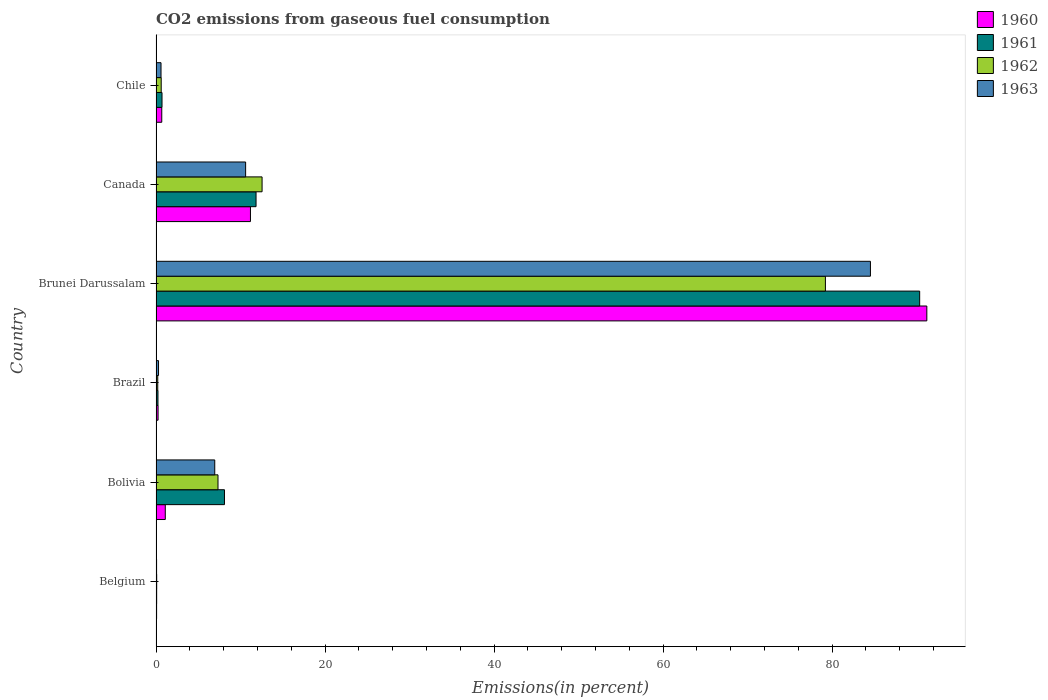How many different coloured bars are there?
Ensure brevity in your answer.  4. Are the number of bars per tick equal to the number of legend labels?
Your answer should be very brief. Yes. Are the number of bars on each tick of the Y-axis equal?
Keep it short and to the point. Yes. How many bars are there on the 1st tick from the top?
Provide a short and direct response. 4. What is the label of the 1st group of bars from the top?
Make the answer very short. Chile. What is the total CO2 emitted in 1960 in Brunei Darussalam?
Offer a terse response. 91.21. Across all countries, what is the maximum total CO2 emitted in 1960?
Provide a succinct answer. 91.21. Across all countries, what is the minimum total CO2 emitted in 1962?
Provide a short and direct response. 0.08. In which country was the total CO2 emitted in 1962 maximum?
Offer a very short reply. Brunei Darussalam. In which country was the total CO2 emitted in 1962 minimum?
Make the answer very short. Belgium. What is the total total CO2 emitted in 1960 in the graph?
Your answer should be very brief. 104.47. What is the difference between the total CO2 emitted in 1961 in Brunei Darussalam and that in Canada?
Make the answer very short. 78.52. What is the difference between the total CO2 emitted in 1960 in Chile and the total CO2 emitted in 1961 in Belgium?
Offer a very short reply. 0.6. What is the average total CO2 emitted in 1961 per country?
Offer a terse response. 18.55. What is the difference between the total CO2 emitted in 1960 and total CO2 emitted in 1961 in Brunei Darussalam?
Your answer should be very brief. 0.85. In how many countries, is the total CO2 emitted in 1961 greater than 56 %?
Offer a terse response. 1. What is the ratio of the total CO2 emitted in 1962 in Brazil to that in Chile?
Ensure brevity in your answer.  0.33. What is the difference between the highest and the second highest total CO2 emitted in 1963?
Ensure brevity in your answer.  73.93. What is the difference between the highest and the lowest total CO2 emitted in 1963?
Provide a short and direct response. 84.47. Is the sum of the total CO2 emitted in 1963 in Canada and Chile greater than the maximum total CO2 emitted in 1962 across all countries?
Your answer should be very brief. No. Is it the case that in every country, the sum of the total CO2 emitted in 1962 and total CO2 emitted in 1960 is greater than the sum of total CO2 emitted in 1963 and total CO2 emitted in 1961?
Make the answer very short. No. What does the 1st bar from the top in Canada represents?
Your response must be concise. 1963. Are all the bars in the graph horizontal?
Make the answer very short. Yes. How many countries are there in the graph?
Your response must be concise. 6. Does the graph contain any zero values?
Give a very brief answer. No. Does the graph contain grids?
Make the answer very short. No. How many legend labels are there?
Your response must be concise. 4. What is the title of the graph?
Provide a short and direct response. CO2 emissions from gaseous fuel consumption. Does "2000" appear as one of the legend labels in the graph?
Keep it short and to the point. No. What is the label or title of the X-axis?
Offer a terse response. Emissions(in percent). What is the Emissions(in percent) of 1960 in Belgium?
Offer a terse response. 0.07. What is the Emissions(in percent) of 1961 in Belgium?
Give a very brief answer. 0.08. What is the Emissions(in percent) of 1962 in Belgium?
Your response must be concise. 0.08. What is the Emissions(in percent) in 1963 in Belgium?
Give a very brief answer. 0.07. What is the Emissions(in percent) in 1960 in Bolivia?
Provide a succinct answer. 1.09. What is the Emissions(in percent) of 1961 in Bolivia?
Keep it short and to the point. 8.1. What is the Emissions(in percent) of 1962 in Bolivia?
Your answer should be very brief. 7.33. What is the Emissions(in percent) in 1963 in Bolivia?
Offer a very short reply. 6.95. What is the Emissions(in percent) in 1960 in Brazil?
Your answer should be very brief. 0.24. What is the Emissions(in percent) of 1961 in Brazil?
Offer a very short reply. 0.23. What is the Emissions(in percent) in 1962 in Brazil?
Keep it short and to the point. 0.2. What is the Emissions(in percent) in 1963 in Brazil?
Keep it short and to the point. 0.3. What is the Emissions(in percent) of 1960 in Brunei Darussalam?
Your response must be concise. 91.21. What is the Emissions(in percent) of 1961 in Brunei Darussalam?
Your response must be concise. 90.36. What is the Emissions(in percent) of 1962 in Brunei Darussalam?
Give a very brief answer. 79.21. What is the Emissions(in percent) of 1963 in Brunei Darussalam?
Ensure brevity in your answer.  84.54. What is the Emissions(in percent) of 1960 in Canada?
Your answer should be very brief. 11.17. What is the Emissions(in percent) of 1961 in Canada?
Your response must be concise. 11.84. What is the Emissions(in percent) in 1962 in Canada?
Make the answer very short. 12.55. What is the Emissions(in percent) in 1963 in Canada?
Keep it short and to the point. 10.6. What is the Emissions(in percent) of 1960 in Chile?
Your answer should be compact. 0.68. What is the Emissions(in percent) in 1961 in Chile?
Make the answer very short. 0.71. What is the Emissions(in percent) of 1962 in Chile?
Offer a terse response. 0.61. What is the Emissions(in percent) of 1963 in Chile?
Offer a terse response. 0.59. Across all countries, what is the maximum Emissions(in percent) of 1960?
Keep it short and to the point. 91.21. Across all countries, what is the maximum Emissions(in percent) of 1961?
Ensure brevity in your answer.  90.36. Across all countries, what is the maximum Emissions(in percent) of 1962?
Provide a succinct answer. 79.21. Across all countries, what is the maximum Emissions(in percent) of 1963?
Provide a succinct answer. 84.54. Across all countries, what is the minimum Emissions(in percent) of 1960?
Provide a succinct answer. 0.07. Across all countries, what is the minimum Emissions(in percent) in 1961?
Offer a very short reply. 0.08. Across all countries, what is the minimum Emissions(in percent) of 1962?
Your response must be concise. 0.08. Across all countries, what is the minimum Emissions(in percent) in 1963?
Keep it short and to the point. 0.07. What is the total Emissions(in percent) in 1960 in the graph?
Your response must be concise. 104.47. What is the total Emissions(in percent) in 1961 in the graph?
Make the answer very short. 111.31. What is the total Emissions(in percent) of 1962 in the graph?
Ensure brevity in your answer.  99.99. What is the total Emissions(in percent) in 1963 in the graph?
Your answer should be very brief. 103.04. What is the difference between the Emissions(in percent) in 1960 in Belgium and that in Bolivia?
Keep it short and to the point. -1.03. What is the difference between the Emissions(in percent) in 1961 in Belgium and that in Bolivia?
Give a very brief answer. -8.02. What is the difference between the Emissions(in percent) in 1962 in Belgium and that in Bolivia?
Your answer should be compact. -7.25. What is the difference between the Emissions(in percent) of 1963 in Belgium and that in Bolivia?
Your answer should be very brief. -6.88. What is the difference between the Emissions(in percent) in 1960 in Belgium and that in Brazil?
Ensure brevity in your answer.  -0.17. What is the difference between the Emissions(in percent) in 1961 in Belgium and that in Brazil?
Give a very brief answer. -0.16. What is the difference between the Emissions(in percent) of 1962 in Belgium and that in Brazil?
Make the answer very short. -0.13. What is the difference between the Emissions(in percent) in 1963 in Belgium and that in Brazil?
Give a very brief answer. -0.23. What is the difference between the Emissions(in percent) of 1960 in Belgium and that in Brunei Darussalam?
Make the answer very short. -91.14. What is the difference between the Emissions(in percent) of 1961 in Belgium and that in Brunei Darussalam?
Offer a terse response. -90.29. What is the difference between the Emissions(in percent) in 1962 in Belgium and that in Brunei Darussalam?
Provide a short and direct response. -79.13. What is the difference between the Emissions(in percent) in 1963 in Belgium and that in Brunei Darussalam?
Provide a short and direct response. -84.47. What is the difference between the Emissions(in percent) in 1960 in Belgium and that in Canada?
Give a very brief answer. -11.11. What is the difference between the Emissions(in percent) of 1961 in Belgium and that in Canada?
Your answer should be very brief. -11.76. What is the difference between the Emissions(in percent) in 1962 in Belgium and that in Canada?
Give a very brief answer. -12.47. What is the difference between the Emissions(in percent) in 1963 in Belgium and that in Canada?
Offer a very short reply. -10.54. What is the difference between the Emissions(in percent) in 1960 in Belgium and that in Chile?
Your response must be concise. -0.61. What is the difference between the Emissions(in percent) in 1961 in Belgium and that in Chile?
Provide a succinct answer. -0.63. What is the difference between the Emissions(in percent) in 1962 in Belgium and that in Chile?
Keep it short and to the point. -0.54. What is the difference between the Emissions(in percent) of 1963 in Belgium and that in Chile?
Your response must be concise. -0.53. What is the difference between the Emissions(in percent) of 1960 in Bolivia and that in Brazil?
Provide a succinct answer. 0.85. What is the difference between the Emissions(in percent) in 1961 in Bolivia and that in Brazil?
Provide a succinct answer. 7.87. What is the difference between the Emissions(in percent) of 1962 in Bolivia and that in Brazil?
Your response must be concise. 7.13. What is the difference between the Emissions(in percent) of 1963 in Bolivia and that in Brazil?
Keep it short and to the point. 6.65. What is the difference between the Emissions(in percent) in 1960 in Bolivia and that in Brunei Darussalam?
Your response must be concise. -90.11. What is the difference between the Emissions(in percent) of 1961 in Bolivia and that in Brunei Darussalam?
Your answer should be compact. -82.26. What is the difference between the Emissions(in percent) of 1962 in Bolivia and that in Brunei Darussalam?
Make the answer very short. -71.87. What is the difference between the Emissions(in percent) in 1963 in Bolivia and that in Brunei Darussalam?
Offer a terse response. -77.59. What is the difference between the Emissions(in percent) in 1960 in Bolivia and that in Canada?
Keep it short and to the point. -10.08. What is the difference between the Emissions(in percent) of 1961 in Bolivia and that in Canada?
Your answer should be compact. -3.74. What is the difference between the Emissions(in percent) of 1962 in Bolivia and that in Canada?
Make the answer very short. -5.22. What is the difference between the Emissions(in percent) of 1963 in Bolivia and that in Canada?
Provide a succinct answer. -3.65. What is the difference between the Emissions(in percent) of 1960 in Bolivia and that in Chile?
Provide a succinct answer. 0.42. What is the difference between the Emissions(in percent) of 1961 in Bolivia and that in Chile?
Keep it short and to the point. 7.39. What is the difference between the Emissions(in percent) of 1962 in Bolivia and that in Chile?
Offer a very short reply. 6.72. What is the difference between the Emissions(in percent) in 1963 in Bolivia and that in Chile?
Give a very brief answer. 6.36. What is the difference between the Emissions(in percent) of 1960 in Brazil and that in Brunei Darussalam?
Your answer should be very brief. -90.97. What is the difference between the Emissions(in percent) of 1961 in Brazil and that in Brunei Darussalam?
Provide a succinct answer. -90.13. What is the difference between the Emissions(in percent) of 1962 in Brazil and that in Brunei Darussalam?
Give a very brief answer. -79. What is the difference between the Emissions(in percent) in 1963 in Brazil and that in Brunei Darussalam?
Keep it short and to the point. -84.24. What is the difference between the Emissions(in percent) in 1960 in Brazil and that in Canada?
Your response must be concise. -10.93. What is the difference between the Emissions(in percent) in 1961 in Brazil and that in Canada?
Your response must be concise. -11.61. What is the difference between the Emissions(in percent) in 1962 in Brazil and that in Canada?
Provide a short and direct response. -12.34. What is the difference between the Emissions(in percent) in 1963 in Brazil and that in Canada?
Provide a succinct answer. -10.31. What is the difference between the Emissions(in percent) in 1960 in Brazil and that in Chile?
Your answer should be very brief. -0.44. What is the difference between the Emissions(in percent) in 1961 in Brazil and that in Chile?
Provide a short and direct response. -0.48. What is the difference between the Emissions(in percent) of 1962 in Brazil and that in Chile?
Your response must be concise. -0.41. What is the difference between the Emissions(in percent) in 1963 in Brazil and that in Chile?
Make the answer very short. -0.29. What is the difference between the Emissions(in percent) in 1960 in Brunei Darussalam and that in Canada?
Your answer should be compact. 80.03. What is the difference between the Emissions(in percent) in 1961 in Brunei Darussalam and that in Canada?
Keep it short and to the point. 78.52. What is the difference between the Emissions(in percent) in 1962 in Brunei Darussalam and that in Canada?
Provide a succinct answer. 66.66. What is the difference between the Emissions(in percent) of 1963 in Brunei Darussalam and that in Canada?
Ensure brevity in your answer.  73.93. What is the difference between the Emissions(in percent) of 1960 in Brunei Darussalam and that in Chile?
Provide a succinct answer. 90.53. What is the difference between the Emissions(in percent) of 1961 in Brunei Darussalam and that in Chile?
Your answer should be very brief. 89.65. What is the difference between the Emissions(in percent) of 1962 in Brunei Darussalam and that in Chile?
Keep it short and to the point. 78.59. What is the difference between the Emissions(in percent) in 1963 in Brunei Darussalam and that in Chile?
Offer a terse response. 83.94. What is the difference between the Emissions(in percent) in 1960 in Canada and that in Chile?
Make the answer very short. 10.49. What is the difference between the Emissions(in percent) in 1961 in Canada and that in Chile?
Provide a succinct answer. 11.13. What is the difference between the Emissions(in percent) in 1962 in Canada and that in Chile?
Keep it short and to the point. 11.93. What is the difference between the Emissions(in percent) of 1963 in Canada and that in Chile?
Offer a very short reply. 10.01. What is the difference between the Emissions(in percent) in 1960 in Belgium and the Emissions(in percent) in 1961 in Bolivia?
Provide a succinct answer. -8.03. What is the difference between the Emissions(in percent) in 1960 in Belgium and the Emissions(in percent) in 1962 in Bolivia?
Offer a very short reply. -7.26. What is the difference between the Emissions(in percent) of 1960 in Belgium and the Emissions(in percent) of 1963 in Bolivia?
Make the answer very short. -6.88. What is the difference between the Emissions(in percent) of 1961 in Belgium and the Emissions(in percent) of 1962 in Bolivia?
Give a very brief answer. -7.26. What is the difference between the Emissions(in percent) in 1961 in Belgium and the Emissions(in percent) in 1963 in Bolivia?
Give a very brief answer. -6.87. What is the difference between the Emissions(in percent) in 1962 in Belgium and the Emissions(in percent) in 1963 in Bolivia?
Ensure brevity in your answer.  -6.87. What is the difference between the Emissions(in percent) in 1960 in Belgium and the Emissions(in percent) in 1961 in Brazil?
Provide a succinct answer. -0.16. What is the difference between the Emissions(in percent) in 1960 in Belgium and the Emissions(in percent) in 1962 in Brazil?
Keep it short and to the point. -0.14. What is the difference between the Emissions(in percent) of 1960 in Belgium and the Emissions(in percent) of 1963 in Brazil?
Make the answer very short. -0.23. What is the difference between the Emissions(in percent) of 1961 in Belgium and the Emissions(in percent) of 1962 in Brazil?
Your answer should be very brief. -0.13. What is the difference between the Emissions(in percent) of 1961 in Belgium and the Emissions(in percent) of 1963 in Brazil?
Make the answer very short. -0.22. What is the difference between the Emissions(in percent) of 1962 in Belgium and the Emissions(in percent) of 1963 in Brazil?
Provide a succinct answer. -0.22. What is the difference between the Emissions(in percent) in 1960 in Belgium and the Emissions(in percent) in 1961 in Brunei Darussalam?
Give a very brief answer. -90.29. What is the difference between the Emissions(in percent) of 1960 in Belgium and the Emissions(in percent) of 1962 in Brunei Darussalam?
Ensure brevity in your answer.  -79.14. What is the difference between the Emissions(in percent) in 1960 in Belgium and the Emissions(in percent) in 1963 in Brunei Darussalam?
Provide a short and direct response. -84.47. What is the difference between the Emissions(in percent) in 1961 in Belgium and the Emissions(in percent) in 1962 in Brunei Darussalam?
Provide a succinct answer. -79.13. What is the difference between the Emissions(in percent) in 1961 in Belgium and the Emissions(in percent) in 1963 in Brunei Darussalam?
Make the answer very short. -84.46. What is the difference between the Emissions(in percent) of 1962 in Belgium and the Emissions(in percent) of 1963 in Brunei Darussalam?
Your response must be concise. -84.46. What is the difference between the Emissions(in percent) in 1960 in Belgium and the Emissions(in percent) in 1961 in Canada?
Keep it short and to the point. -11.77. What is the difference between the Emissions(in percent) of 1960 in Belgium and the Emissions(in percent) of 1962 in Canada?
Provide a short and direct response. -12.48. What is the difference between the Emissions(in percent) of 1960 in Belgium and the Emissions(in percent) of 1963 in Canada?
Keep it short and to the point. -10.53. What is the difference between the Emissions(in percent) in 1961 in Belgium and the Emissions(in percent) in 1962 in Canada?
Provide a short and direct response. -12.47. What is the difference between the Emissions(in percent) of 1961 in Belgium and the Emissions(in percent) of 1963 in Canada?
Provide a short and direct response. -10.53. What is the difference between the Emissions(in percent) in 1962 in Belgium and the Emissions(in percent) in 1963 in Canada?
Give a very brief answer. -10.52. What is the difference between the Emissions(in percent) of 1960 in Belgium and the Emissions(in percent) of 1961 in Chile?
Give a very brief answer. -0.64. What is the difference between the Emissions(in percent) in 1960 in Belgium and the Emissions(in percent) in 1962 in Chile?
Offer a terse response. -0.55. What is the difference between the Emissions(in percent) in 1960 in Belgium and the Emissions(in percent) in 1963 in Chile?
Provide a succinct answer. -0.52. What is the difference between the Emissions(in percent) in 1961 in Belgium and the Emissions(in percent) in 1962 in Chile?
Keep it short and to the point. -0.54. What is the difference between the Emissions(in percent) in 1961 in Belgium and the Emissions(in percent) in 1963 in Chile?
Offer a terse response. -0.52. What is the difference between the Emissions(in percent) of 1962 in Belgium and the Emissions(in percent) of 1963 in Chile?
Give a very brief answer. -0.51. What is the difference between the Emissions(in percent) of 1960 in Bolivia and the Emissions(in percent) of 1961 in Brazil?
Provide a short and direct response. 0.86. What is the difference between the Emissions(in percent) in 1960 in Bolivia and the Emissions(in percent) in 1962 in Brazil?
Make the answer very short. 0.89. What is the difference between the Emissions(in percent) of 1960 in Bolivia and the Emissions(in percent) of 1963 in Brazil?
Make the answer very short. 0.8. What is the difference between the Emissions(in percent) of 1961 in Bolivia and the Emissions(in percent) of 1962 in Brazil?
Provide a succinct answer. 7.89. What is the difference between the Emissions(in percent) of 1961 in Bolivia and the Emissions(in percent) of 1963 in Brazil?
Ensure brevity in your answer.  7.8. What is the difference between the Emissions(in percent) of 1962 in Bolivia and the Emissions(in percent) of 1963 in Brazil?
Provide a succinct answer. 7.04. What is the difference between the Emissions(in percent) in 1960 in Bolivia and the Emissions(in percent) in 1961 in Brunei Darussalam?
Provide a succinct answer. -89.27. What is the difference between the Emissions(in percent) of 1960 in Bolivia and the Emissions(in percent) of 1962 in Brunei Darussalam?
Provide a short and direct response. -78.11. What is the difference between the Emissions(in percent) of 1960 in Bolivia and the Emissions(in percent) of 1963 in Brunei Darussalam?
Provide a short and direct response. -83.44. What is the difference between the Emissions(in percent) of 1961 in Bolivia and the Emissions(in percent) of 1962 in Brunei Darussalam?
Ensure brevity in your answer.  -71.11. What is the difference between the Emissions(in percent) in 1961 in Bolivia and the Emissions(in percent) in 1963 in Brunei Darussalam?
Offer a very short reply. -76.44. What is the difference between the Emissions(in percent) in 1962 in Bolivia and the Emissions(in percent) in 1963 in Brunei Darussalam?
Give a very brief answer. -77.2. What is the difference between the Emissions(in percent) in 1960 in Bolivia and the Emissions(in percent) in 1961 in Canada?
Offer a terse response. -10.74. What is the difference between the Emissions(in percent) of 1960 in Bolivia and the Emissions(in percent) of 1962 in Canada?
Your response must be concise. -11.45. What is the difference between the Emissions(in percent) of 1960 in Bolivia and the Emissions(in percent) of 1963 in Canada?
Your answer should be very brief. -9.51. What is the difference between the Emissions(in percent) of 1961 in Bolivia and the Emissions(in percent) of 1962 in Canada?
Provide a succinct answer. -4.45. What is the difference between the Emissions(in percent) of 1961 in Bolivia and the Emissions(in percent) of 1963 in Canada?
Give a very brief answer. -2.5. What is the difference between the Emissions(in percent) of 1962 in Bolivia and the Emissions(in percent) of 1963 in Canada?
Ensure brevity in your answer.  -3.27. What is the difference between the Emissions(in percent) of 1960 in Bolivia and the Emissions(in percent) of 1961 in Chile?
Your response must be concise. 0.39. What is the difference between the Emissions(in percent) in 1960 in Bolivia and the Emissions(in percent) in 1962 in Chile?
Provide a succinct answer. 0.48. What is the difference between the Emissions(in percent) of 1960 in Bolivia and the Emissions(in percent) of 1963 in Chile?
Your answer should be very brief. 0.5. What is the difference between the Emissions(in percent) of 1961 in Bolivia and the Emissions(in percent) of 1962 in Chile?
Your response must be concise. 7.48. What is the difference between the Emissions(in percent) in 1961 in Bolivia and the Emissions(in percent) in 1963 in Chile?
Ensure brevity in your answer.  7.51. What is the difference between the Emissions(in percent) in 1962 in Bolivia and the Emissions(in percent) in 1963 in Chile?
Provide a short and direct response. 6.74. What is the difference between the Emissions(in percent) in 1960 in Brazil and the Emissions(in percent) in 1961 in Brunei Darussalam?
Your answer should be very brief. -90.12. What is the difference between the Emissions(in percent) in 1960 in Brazil and the Emissions(in percent) in 1962 in Brunei Darussalam?
Offer a terse response. -78.97. What is the difference between the Emissions(in percent) of 1960 in Brazil and the Emissions(in percent) of 1963 in Brunei Darussalam?
Your response must be concise. -84.29. What is the difference between the Emissions(in percent) of 1961 in Brazil and the Emissions(in percent) of 1962 in Brunei Darussalam?
Provide a short and direct response. -78.98. What is the difference between the Emissions(in percent) in 1961 in Brazil and the Emissions(in percent) in 1963 in Brunei Darussalam?
Your response must be concise. -84.31. What is the difference between the Emissions(in percent) of 1962 in Brazil and the Emissions(in percent) of 1963 in Brunei Darussalam?
Your answer should be very brief. -84.33. What is the difference between the Emissions(in percent) in 1960 in Brazil and the Emissions(in percent) in 1961 in Canada?
Provide a short and direct response. -11.59. What is the difference between the Emissions(in percent) in 1960 in Brazil and the Emissions(in percent) in 1962 in Canada?
Your answer should be very brief. -12.31. What is the difference between the Emissions(in percent) of 1960 in Brazil and the Emissions(in percent) of 1963 in Canada?
Offer a terse response. -10.36. What is the difference between the Emissions(in percent) in 1961 in Brazil and the Emissions(in percent) in 1962 in Canada?
Offer a terse response. -12.32. What is the difference between the Emissions(in percent) in 1961 in Brazil and the Emissions(in percent) in 1963 in Canada?
Your answer should be very brief. -10.37. What is the difference between the Emissions(in percent) in 1962 in Brazil and the Emissions(in percent) in 1963 in Canada?
Make the answer very short. -10.4. What is the difference between the Emissions(in percent) in 1960 in Brazil and the Emissions(in percent) in 1961 in Chile?
Make the answer very short. -0.47. What is the difference between the Emissions(in percent) in 1960 in Brazil and the Emissions(in percent) in 1962 in Chile?
Give a very brief answer. -0.37. What is the difference between the Emissions(in percent) of 1960 in Brazil and the Emissions(in percent) of 1963 in Chile?
Keep it short and to the point. -0.35. What is the difference between the Emissions(in percent) in 1961 in Brazil and the Emissions(in percent) in 1962 in Chile?
Offer a terse response. -0.38. What is the difference between the Emissions(in percent) in 1961 in Brazil and the Emissions(in percent) in 1963 in Chile?
Offer a terse response. -0.36. What is the difference between the Emissions(in percent) of 1962 in Brazil and the Emissions(in percent) of 1963 in Chile?
Keep it short and to the point. -0.39. What is the difference between the Emissions(in percent) in 1960 in Brunei Darussalam and the Emissions(in percent) in 1961 in Canada?
Provide a short and direct response. 79.37. What is the difference between the Emissions(in percent) in 1960 in Brunei Darussalam and the Emissions(in percent) in 1962 in Canada?
Keep it short and to the point. 78.66. What is the difference between the Emissions(in percent) of 1960 in Brunei Darussalam and the Emissions(in percent) of 1963 in Canada?
Give a very brief answer. 80.61. What is the difference between the Emissions(in percent) in 1961 in Brunei Darussalam and the Emissions(in percent) in 1962 in Canada?
Your answer should be compact. 77.81. What is the difference between the Emissions(in percent) of 1961 in Brunei Darussalam and the Emissions(in percent) of 1963 in Canada?
Provide a succinct answer. 79.76. What is the difference between the Emissions(in percent) in 1962 in Brunei Darussalam and the Emissions(in percent) in 1963 in Canada?
Provide a short and direct response. 68.61. What is the difference between the Emissions(in percent) in 1960 in Brunei Darussalam and the Emissions(in percent) in 1961 in Chile?
Offer a very short reply. 90.5. What is the difference between the Emissions(in percent) of 1960 in Brunei Darussalam and the Emissions(in percent) of 1962 in Chile?
Your response must be concise. 90.59. What is the difference between the Emissions(in percent) in 1960 in Brunei Darussalam and the Emissions(in percent) in 1963 in Chile?
Offer a very short reply. 90.62. What is the difference between the Emissions(in percent) of 1961 in Brunei Darussalam and the Emissions(in percent) of 1962 in Chile?
Your answer should be very brief. 89.75. What is the difference between the Emissions(in percent) of 1961 in Brunei Darussalam and the Emissions(in percent) of 1963 in Chile?
Provide a succinct answer. 89.77. What is the difference between the Emissions(in percent) in 1962 in Brunei Darussalam and the Emissions(in percent) in 1963 in Chile?
Your answer should be very brief. 78.62. What is the difference between the Emissions(in percent) of 1960 in Canada and the Emissions(in percent) of 1961 in Chile?
Keep it short and to the point. 10.46. What is the difference between the Emissions(in percent) in 1960 in Canada and the Emissions(in percent) in 1962 in Chile?
Make the answer very short. 10.56. What is the difference between the Emissions(in percent) of 1960 in Canada and the Emissions(in percent) of 1963 in Chile?
Give a very brief answer. 10.58. What is the difference between the Emissions(in percent) of 1961 in Canada and the Emissions(in percent) of 1962 in Chile?
Make the answer very short. 11.22. What is the difference between the Emissions(in percent) in 1961 in Canada and the Emissions(in percent) in 1963 in Chile?
Your response must be concise. 11.25. What is the difference between the Emissions(in percent) of 1962 in Canada and the Emissions(in percent) of 1963 in Chile?
Offer a terse response. 11.96. What is the average Emissions(in percent) in 1960 per country?
Your response must be concise. 17.41. What is the average Emissions(in percent) of 1961 per country?
Make the answer very short. 18.55. What is the average Emissions(in percent) in 1962 per country?
Your response must be concise. 16.66. What is the average Emissions(in percent) in 1963 per country?
Your answer should be very brief. 17.17. What is the difference between the Emissions(in percent) of 1960 and Emissions(in percent) of 1961 in Belgium?
Give a very brief answer. -0.01. What is the difference between the Emissions(in percent) of 1960 and Emissions(in percent) of 1962 in Belgium?
Provide a short and direct response. -0.01. What is the difference between the Emissions(in percent) of 1960 and Emissions(in percent) of 1963 in Belgium?
Make the answer very short. 0. What is the difference between the Emissions(in percent) in 1961 and Emissions(in percent) in 1962 in Belgium?
Provide a succinct answer. -0. What is the difference between the Emissions(in percent) in 1961 and Emissions(in percent) in 1963 in Belgium?
Your answer should be very brief. 0.01. What is the difference between the Emissions(in percent) in 1962 and Emissions(in percent) in 1963 in Belgium?
Offer a terse response. 0.01. What is the difference between the Emissions(in percent) in 1960 and Emissions(in percent) in 1961 in Bolivia?
Ensure brevity in your answer.  -7. What is the difference between the Emissions(in percent) in 1960 and Emissions(in percent) in 1962 in Bolivia?
Your answer should be compact. -6.24. What is the difference between the Emissions(in percent) of 1960 and Emissions(in percent) of 1963 in Bolivia?
Your response must be concise. -5.85. What is the difference between the Emissions(in percent) of 1961 and Emissions(in percent) of 1962 in Bolivia?
Ensure brevity in your answer.  0.77. What is the difference between the Emissions(in percent) in 1961 and Emissions(in percent) in 1963 in Bolivia?
Offer a very short reply. 1.15. What is the difference between the Emissions(in percent) in 1962 and Emissions(in percent) in 1963 in Bolivia?
Give a very brief answer. 0.38. What is the difference between the Emissions(in percent) of 1960 and Emissions(in percent) of 1961 in Brazil?
Provide a short and direct response. 0.01. What is the difference between the Emissions(in percent) in 1960 and Emissions(in percent) in 1962 in Brazil?
Ensure brevity in your answer.  0.04. What is the difference between the Emissions(in percent) of 1960 and Emissions(in percent) of 1963 in Brazil?
Your answer should be compact. -0.05. What is the difference between the Emissions(in percent) in 1961 and Emissions(in percent) in 1962 in Brazil?
Ensure brevity in your answer.  0.03. What is the difference between the Emissions(in percent) of 1961 and Emissions(in percent) of 1963 in Brazil?
Ensure brevity in your answer.  -0.07. What is the difference between the Emissions(in percent) of 1962 and Emissions(in percent) of 1963 in Brazil?
Ensure brevity in your answer.  -0.09. What is the difference between the Emissions(in percent) of 1960 and Emissions(in percent) of 1961 in Brunei Darussalam?
Give a very brief answer. 0.85. What is the difference between the Emissions(in percent) in 1960 and Emissions(in percent) in 1962 in Brunei Darussalam?
Provide a short and direct response. 12. What is the difference between the Emissions(in percent) of 1960 and Emissions(in percent) of 1963 in Brunei Darussalam?
Make the answer very short. 6.67. What is the difference between the Emissions(in percent) of 1961 and Emissions(in percent) of 1962 in Brunei Darussalam?
Ensure brevity in your answer.  11.15. What is the difference between the Emissions(in percent) of 1961 and Emissions(in percent) of 1963 in Brunei Darussalam?
Your response must be concise. 5.83. What is the difference between the Emissions(in percent) in 1962 and Emissions(in percent) in 1963 in Brunei Darussalam?
Your answer should be compact. -5.33. What is the difference between the Emissions(in percent) in 1960 and Emissions(in percent) in 1961 in Canada?
Your answer should be compact. -0.66. What is the difference between the Emissions(in percent) of 1960 and Emissions(in percent) of 1962 in Canada?
Provide a succinct answer. -1.37. What is the difference between the Emissions(in percent) in 1960 and Emissions(in percent) in 1963 in Canada?
Keep it short and to the point. 0.57. What is the difference between the Emissions(in percent) in 1961 and Emissions(in percent) in 1962 in Canada?
Provide a short and direct response. -0.71. What is the difference between the Emissions(in percent) of 1961 and Emissions(in percent) of 1963 in Canada?
Offer a very short reply. 1.23. What is the difference between the Emissions(in percent) of 1962 and Emissions(in percent) of 1963 in Canada?
Provide a short and direct response. 1.95. What is the difference between the Emissions(in percent) of 1960 and Emissions(in percent) of 1961 in Chile?
Your answer should be compact. -0.03. What is the difference between the Emissions(in percent) of 1960 and Emissions(in percent) of 1962 in Chile?
Provide a succinct answer. 0.07. What is the difference between the Emissions(in percent) of 1960 and Emissions(in percent) of 1963 in Chile?
Make the answer very short. 0.09. What is the difference between the Emissions(in percent) of 1961 and Emissions(in percent) of 1962 in Chile?
Keep it short and to the point. 0.1. What is the difference between the Emissions(in percent) in 1961 and Emissions(in percent) in 1963 in Chile?
Ensure brevity in your answer.  0.12. What is the difference between the Emissions(in percent) of 1962 and Emissions(in percent) of 1963 in Chile?
Your answer should be compact. 0.02. What is the ratio of the Emissions(in percent) of 1960 in Belgium to that in Bolivia?
Offer a terse response. 0.06. What is the ratio of the Emissions(in percent) in 1961 in Belgium to that in Bolivia?
Keep it short and to the point. 0.01. What is the ratio of the Emissions(in percent) in 1962 in Belgium to that in Bolivia?
Make the answer very short. 0.01. What is the ratio of the Emissions(in percent) of 1963 in Belgium to that in Bolivia?
Offer a very short reply. 0.01. What is the ratio of the Emissions(in percent) in 1960 in Belgium to that in Brazil?
Make the answer very short. 0.28. What is the ratio of the Emissions(in percent) of 1961 in Belgium to that in Brazil?
Ensure brevity in your answer.  0.33. What is the ratio of the Emissions(in percent) in 1962 in Belgium to that in Brazil?
Your response must be concise. 0.38. What is the ratio of the Emissions(in percent) of 1963 in Belgium to that in Brazil?
Your answer should be very brief. 0.22. What is the ratio of the Emissions(in percent) in 1960 in Belgium to that in Brunei Darussalam?
Your response must be concise. 0. What is the ratio of the Emissions(in percent) in 1961 in Belgium to that in Brunei Darussalam?
Ensure brevity in your answer.  0. What is the ratio of the Emissions(in percent) of 1963 in Belgium to that in Brunei Darussalam?
Your answer should be compact. 0. What is the ratio of the Emissions(in percent) in 1960 in Belgium to that in Canada?
Provide a short and direct response. 0.01. What is the ratio of the Emissions(in percent) in 1961 in Belgium to that in Canada?
Offer a very short reply. 0.01. What is the ratio of the Emissions(in percent) of 1962 in Belgium to that in Canada?
Your response must be concise. 0.01. What is the ratio of the Emissions(in percent) in 1963 in Belgium to that in Canada?
Make the answer very short. 0.01. What is the ratio of the Emissions(in percent) in 1960 in Belgium to that in Chile?
Offer a terse response. 0.1. What is the ratio of the Emissions(in percent) of 1961 in Belgium to that in Chile?
Keep it short and to the point. 0.11. What is the ratio of the Emissions(in percent) in 1962 in Belgium to that in Chile?
Offer a very short reply. 0.13. What is the ratio of the Emissions(in percent) in 1963 in Belgium to that in Chile?
Offer a very short reply. 0.11. What is the ratio of the Emissions(in percent) in 1960 in Bolivia to that in Brazil?
Make the answer very short. 4.52. What is the ratio of the Emissions(in percent) in 1961 in Bolivia to that in Brazil?
Your answer should be very brief. 35.05. What is the ratio of the Emissions(in percent) in 1962 in Bolivia to that in Brazil?
Your response must be concise. 35.79. What is the ratio of the Emissions(in percent) in 1963 in Bolivia to that in Brazil?
Make the answer very short. 23.42. What is the ratio of the Emissions(in percent) in 1960 in Bolivia to that in Brunei Darussalam?
Ensure brevity in your answer.  0.01. What is the ratio of the Emissions(in percent) of 1961 in Bolivia to that in Brunei Darussalam?
Ensure brevity in your answer.  0.09. What is the ratio of the Emissions(in percent) in 1962 in Bolivia to that in Brunei Darussalam?
Offer a terse response. 0.09. What is the ratio of the Emissions(in percent) in 1963 in Bolivia to that in Brunei Darussalam?
Your answer should be very brief. 0.08. What is the ratio of the Emissions(in percent) of 1960 in Bolivia to that in Canada?
Provide a short and direct response. 0.1. What is the ratio of the Emissions(in percent) of 1961 in Bolivia to that in Canada?
Provide a succinct answer. 0.68. What is the ratio of the Emissions(in percent) of 1962 in Bolivia to that in Canada?
Offer a terse response. 0.58. What is the ratio of the Emissions(in percent) in 1963 in Bolivia to that in Canada?
Your answer should be compact. 0.66. What is the ratio of the Emissions(in percent) in 1960 in Bolivia to that in Chile?
Provide a short and direct response. 1.61. What is the ratio of the Emissions(in percent) of 1961 in Bolivia to that in Chile?
Offer a very short reply. 11.42. What is the ratio of the Emissions(in percent) of 1962 in Bolivia to that in Chile?
Provide a succinct answer. 11.95. What is the ratio of the Emissions(in percent) in 1963 in Bolivia to that in Chile?
Keep it short and to the point. 11.75. What is the ratio of the Emissions(in percent) of 1960 in Brazil to that in Brunei Darussalam?
Your answer should be very brief. 0. What is the ratio of the Emissions(in percent) in 1961 in Brazil to that in Brunei Darussalam?
Offer a terse response. 0. What is the ratio of the Emissions(in percent) in 1962 in Brazil to that in Brunei Darussalam?
Provide a succinct answer. 0. What is the ratio of the Emissions(in percent) in 1963 in Brazil to that in Brunei Darussalam?
Give a very brief answer. 0. What is the ratio of the Emissions(in percent) in 1960 in Brazil to that in Canada?
Your answer should be compact. 0.02. What is the ratio of the Emissions(in percent) in 1961 in Brazil to that in Canada?
Make the answer very short. 0.02. What is the ratio of the Emissions(in percent) in 1962 in Brazil to that in Canada?
Provide a short and direct response. 0.02. What is the ratio of the Emissions(in percent) in 1963 in Brazil to that in Canada?
Your answer should be compact. 0.03. What is the ratio of the Emissions(in percent) in 1960 in Brazil to that in Chile?
Give a very brief answer. 0.36. What is the ratio of the Emissions(in percent) of 1961 in Brazil to that in Chile?
Give a very brief answer. 0.33. What is the ratio of the Emissions(in percent) in 1962 in Brazil to that in Chile?
Keep it short and to the point. 0.33. What is the ratio of the Emissions(in percent) of 1963 in Brazil to that in Chile?
Keep it short and to the point. 0.5. What is the ratio of the Emissions(in percent) of 1960 in Brunei Darussalam to that in Canada?
Your answer should be compact. 8.16. What is the ratio of the Emissions(in percent) in 1961 in Brunei Darussalam to that in Canada?
Offer a terse response. 7.63. What is the ratio of the Emissions(in percent) in 1962 in Brunei Darussalam to that in Canada?
Provide a succinct answer. 6.31. What is the ratio of the Emissions(in percent) of 1963 in Brunei Darussalam to that in Canada?
Make the answer very short. 7.97. What is the ratio of the Emissions(in percent) in 1960 in Brunei Darussalam to that in Chile?
Give a very brief answer. 134.22. What is the ratio of the Emissions(in percent) of 1961 in Brunei Darussalam to that in Chile?
Your answer should be compact. 127.38. What is the ratio of the Emissions(in percent) in 1962 in Brunei Darussalam to that in Chile?
Offer a terse response. 129.02. What is the ratio of the Emissions(in percent) of 1963 in Brunei Darussalam to that in Chile?
Ensure brevity in your answer.  142.9. What is the ratio of the Emissions(in percent) of 1960 in Canada to that in Chile?
Your response must be concise. 16.44. What is the ratio of the Emissions(in percent) of 1961 in Canada to that in Chile?
Your response must be concise. 16.69. What is the ratio of the Emissions(in percent) of 1962 in Canada to that in Chile?
Your response must be concise. 20.44. What is the ratio of the Emissions(in percent) in 1963 in Canada to that in Chile?
Make the answer very short. 17.92. What is the difference between the highest and the second highest Emissions(in percent) of 1960?
Give a very brief answer. 80.03. What is the difference between the highest and the second highest Emissions(in percent) in 1961?
Keep it short and to the point. 78.52. What is the difference between the highest and the second highest Emissions(in percent) in 1962?
Your answer should be very brief. 66.66. What is the difference between the highest and the second highest Emissions(in percent) of 1963?
Your answer should be very brief. 73.93. What is the difference between the highest and the lowest Emissions(in percent) of 1960?
Give a very brief answer. 91.14. What is the difference between the highest and the lowest Emissions(in percent) in 1961?
Give a very brief answer. 90.29. What is the difference between the highest and the lowest Emissions(in percent) in 1962?
Provide a succinct answer. 79.13. What is the difference between the highest and the lowest Emissions(in percent) in 1963?
Keep it short and to the point. 84.47. 